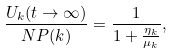Convert formula to latex. <formula><loc_0><loc_0><loc_500><loc_500>\frac { U _ { k } ( t \rightarrow \infty ) } { N P ( k ) } = \frac { 1 } { 1 + \frac { \eta _ { k } } { \mu _ { k } } } ,</formula> 